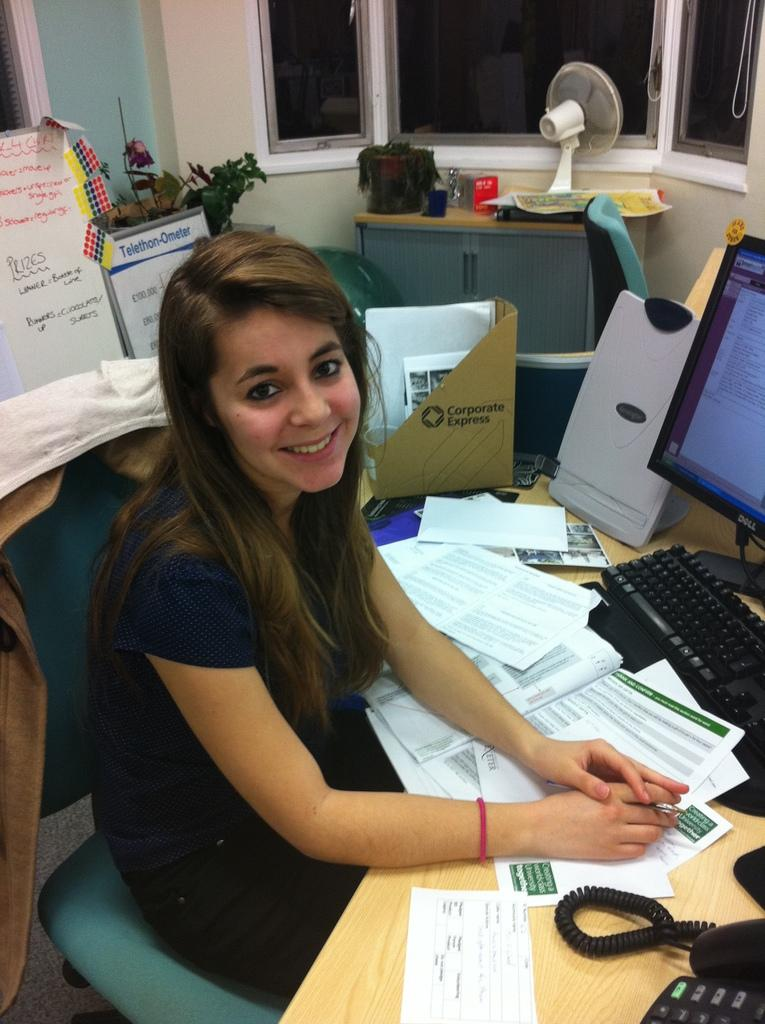<image>
Offer a succinct explanation of the picture presented. A woman working on a computer near a folder labeled Corporate Express 